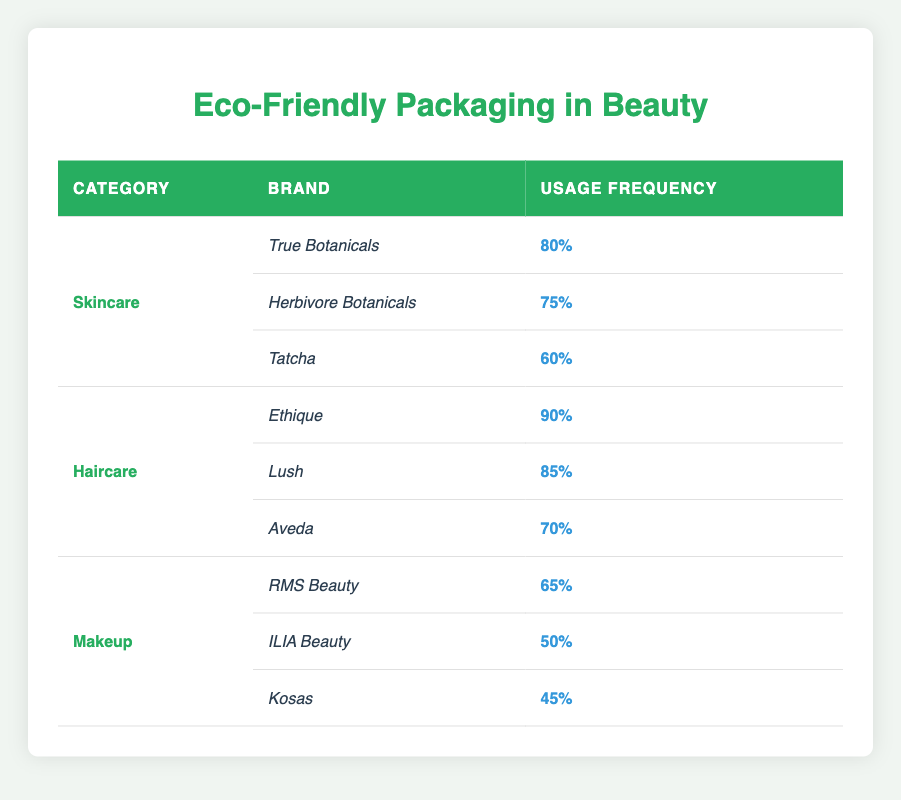What is the brand with the highest usage frequency of eco-friendly packaging in the skincare category? Looking at the skincare section, True Botanicals has the highest usage frequency at 80%.
Answer: True Botanicals Is Lush an eco-friendly brand used in the haircare category? Yes, Lush is listed under the haircare category with an eco-friendly packaging usage frequency of 85%.
Answer: Yes What is the average eco-friendly packaging usage frequency for the haircare category? The usage frequencies for haircare are 90%, 85%, and 70%. Adding them gives 90 + 85 + 70 = 245. There are 3 brands, so the average is 245 / 3 = 81.67%.
Answer: 81.67% Are any makeup brands listed with a usage frequency higher than 60%? Only RMS Beauty in the makeup category has a usage frequency of 65%, which is the only value above 60%.
Answer: Yes Which beauty category has the lowest average eco-friendly packaging usage frequency? The averages for each category are: Skincare (80 + 75 + 60) / 3 = 71.67%, Haircare (90 + 85 + 70) / 3 = 81.67%, and Makeup (65 + 50 + 45) / 3 = 53.33%. Makeup has the lowest average of 53.33%.
Answer: Makeup What percentage of makeup brands use eco-friendly packaging below 50%? Only one makeup brand, Kosas, has a usage frequency of 45%, which is below 50%.
Answer: Yes Which brand in skincare has the smallest presence of eco-friendly packaging? Tatcha has the lowest usage frequency in the skincare category at 60%.
Answer: Tatcha What is the difference in usage frequency between the highest and lowest brand in the haircare category? The highest is Ethique with 90% and the lowest is Aveda with 70%. The difference is 90 - 70 = 20%.
Answer: 20% 